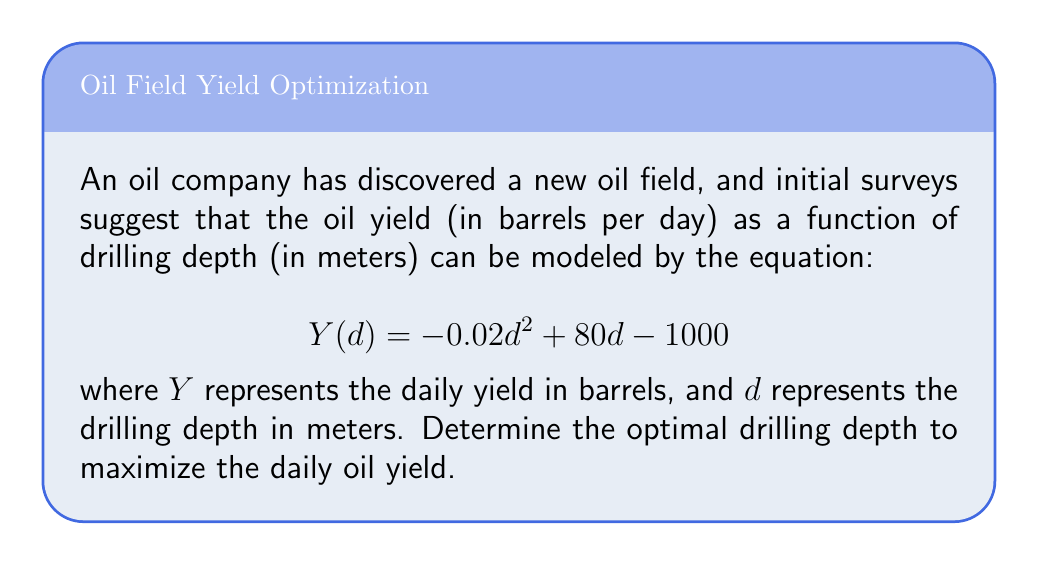Give your solution to this math problem. To find the optimal drilling depth for maximum yield, we need to find the maximum point of the function $Y(d)$. This can be done by following these steps:

1. Find the derivative of $Y(d)$ with respect to $d$:
   $$Y'(d) = \frac{d}{dd}(-0.02d^2 + 80d - 1000)$$
   $$Y'(d) = -0.04d + 80$$

2. Set the derivative equal to zero to find the critical point:
   $$-0.04d + 80 = 0$$
   $$-0.04d = -80$$
   $$d = \frac{-80}{-0.04} = 2000$$

3. Verify that this critical point is a maximum by checking the second derivative:
   $$Y''(d) = \frac{d}{dd}(-0.04d + 80) = -0.04$$
   Since $Y''(d)$ is negative, the critical point is a maximum.

4. Therefore, the optimal drilling depth is 2000 meters.

5. To calculate the maximum yield, substitute $d = 2000$ into the original function:
   $$Y(2000) = -0.02(2000)^2 + 80(2000) - 1000$$
   $$= -80000 + 160000 - 1000 = 79000$$

Thus, the maximum daily yield is 79,000 barrels per day at a depth of 2000 meters.
Answer: 2000 meters 